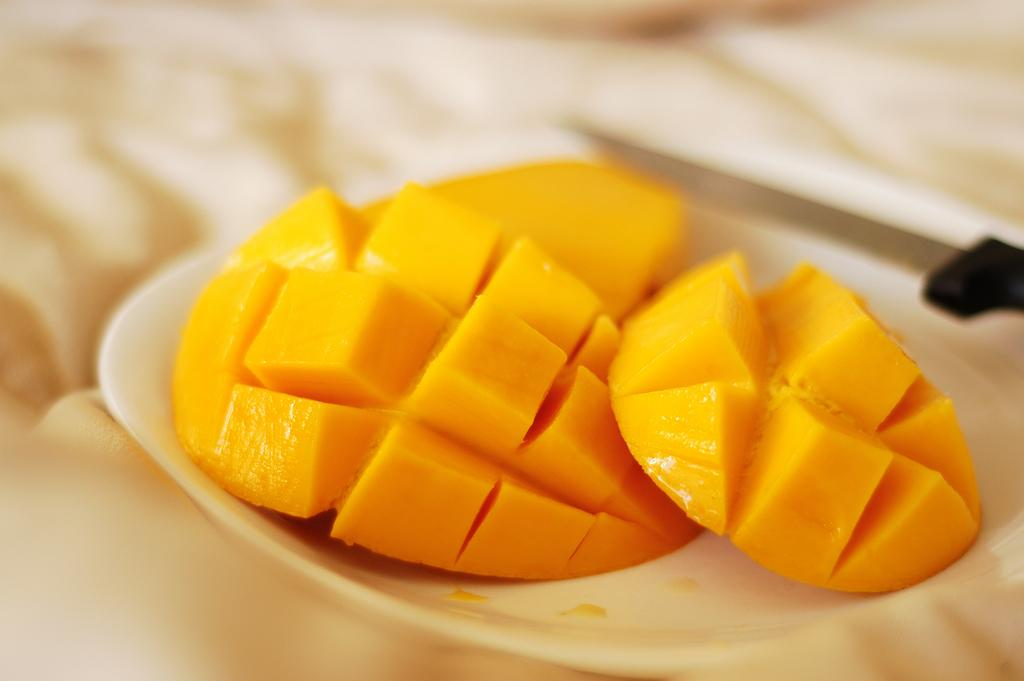What is on the plate in the image? There is food on the plate in the image. Can you describe the background of the image? The background of the image is blurry. What type of crayon is being used by the women at the market in the image? There are no women or market present in the image, and therefore no crayon usage can be observed. 